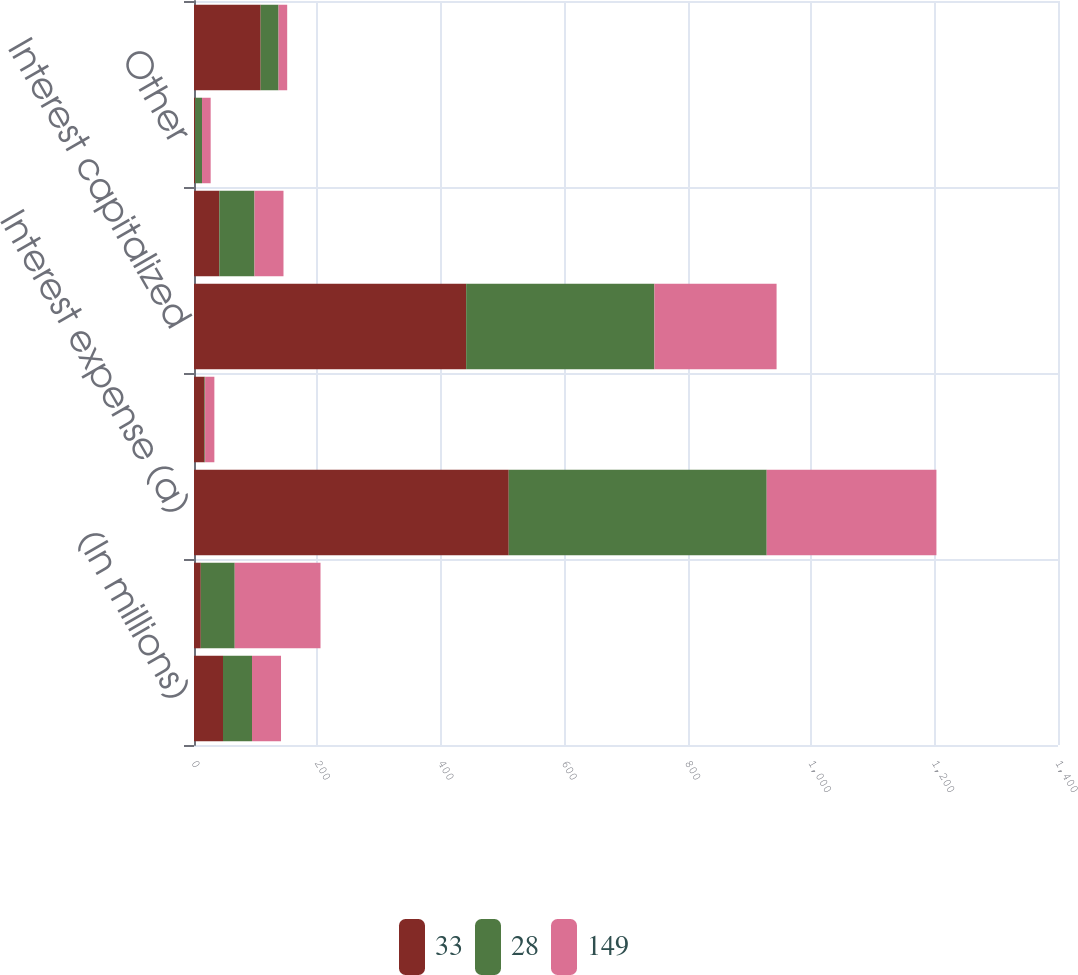Convert chart. <chart><loc_0><loc_0><loc_500><loc_500><stacked_bar_chart><ecel><fcel>(In millions)<fcel>Interest income<fcel>Interest expense (a)<fcel>Income (loss) on interest rate<fcel>Interest capitalized<fcel>Total interest<fcel>Other<fcel>Total other<nl><fcel>33<fcel>47<fcel>11<fcel>510<fcel>17<fcel>441<fcel>41<fcel>2<fcel>108<nl><fcel>28<fcel>47<fcel>55<fcel>418<fcel>1<fcel>305<fcel>57<fcel>11<fcel>29<nl><fcel>149<fcel>47<fcel>139<fcel>275<fcel>15<fcel>198<fcel>47<fcel>14<fcel>14<nl></chart> 